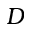Convert formula to latex. <formula><loc_0><loc_0><loc_500><loc_500>D</formula> 